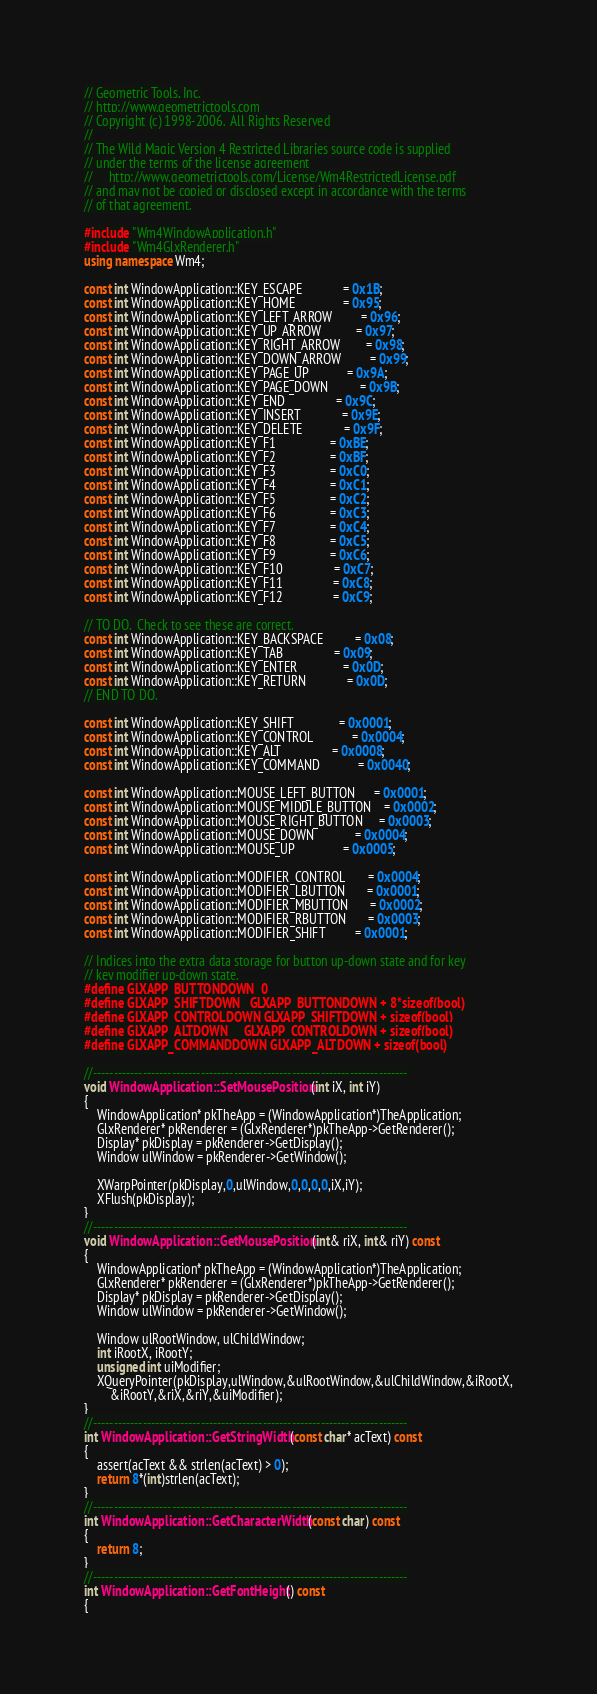Convert code to text. <code><loc_0><loc_0><loc_500><loc_500><_C++_>// Geometric Tools, Inc.
// http://www.geometrictools.com
// Copyright (c) 1998-2006.  All Rights Reserved
//
// The Wild Magic Version 4 Restricted Libraries source code is supplied
// under the terms of the license agreement
//     http://www.geometrictools.com/License/Wm4RestrictedLicense.pdf
// and may not be copied or disclosed except in accordance with the terms
// of that agreement.

#include "Wm4WindowApplication.h"
#include "Wm4GlxRenderer.h"
using namespace Wm4;

const int WindowApplication::KEY_ESCAPE             = 0x1B;
const int WindowApplication::KEY_HOME               = 0x95;
const int WindowApplication::KEY_LEFT_ARROW         = 0x96;
const int WindowApplication::KEY_UP_ARROW           = 0x97;
const int WindowApplication::KEY_RIGHT_ARROW        = 0x98;
const int WindowApplication::KEY_DOWN_ARROW         = 0x99;
const int WindowApplication::KEY_PAGE_UP            = 0x9A;
const int WindowApplication::KEY_PAGE_DOWN          = 0x9B;
const int WindowApplication::KEY_END                = 0x9C;
const int WindowApplication::KEY_INSERT             = 0x9E;
const int WindowApplication::KEY_DELETE             = 0x9F;
const int WindowApplication::KEY_F1                 = 0xBE;
const int WindowApplication::KEY_F2                 = 0xBF;
const int WindowApplication::KEY_F3                 = 0xC0;
const int WindowApplication::KEY_F4                 = 0xC1;
const int WindowApplication::KEY_F5                 = 0xC2;
const int WindowApplication::KEY_F6                 = 0xC3;
const int WindowApplication::KEY_F7                 = 0xC4;
const int WindowApplication::KEY_F8                 = 0xC5;
const int WindowApplication::KEY_F9                 = 0xC6;
const int WindowApplication::KEY_F10                = 0xC7;
const int WindowApplication::KEY_F11                = 0xC8;
const int WindowApplication::KEY_F12                = 0xC9;

// TO DO.  Check to see these are correct.
const int WindowApplication::KEY_BACKSPACE          = 0x08;
const int WindowApplication::KEY_TAB                = 0x09;
const int WindowApplication::KEY_ENTER              = 0x0D;
const int WindowApplication::KEY_RETURN             = 0x0D;
// END TO DO.

const int WindowApplication::KEY_SHIFT              = 0x0001;
const int WindowApplication::KEY_CONTROL            = 0x0004;
const int WindowApplication::KEY_ALT                = 0x0008;
const int WindowApplication::KEY_COMMAND            = 0x0040;

const int WindowApplication::MOUSE_LEFT_BUTTON      = 0x0001;
const int WindowApplication::MOUSE_MIDDLE_BUTTON    = 0x0002;
const int WindowApplication::MOUSE_RIGHT_BUTTON     = 0x0003;
const int WindowApplication::MOUSE_DOWN             = 0x0004;
const int WindowApplication::MOUSE_UP               = 0x0005;

const int WindowApplication::MODIFIER_CONTROL       = 0x0004;
const int WindowApplication::MODIFIER_LBUTTON       = 0x0001;
const int WindowApplication::MODIFIER_MBUTTON       = 0x0002;
const int WindowApplication::MODIFIER_RBUTTON       = 0x0003;
const int WindowApplication::MODIFIER_SHIFT         = 0x0001;

// Indices into the extra data storage for button up-down state and for key
// key modifier up-down state.
#define GLXAPP_BUTTONDOWN  0
#define GLXAPP_SHIFTDOWN   GLXAPP_BUTTONDOWN + 8*sizeof(bool)
#define GLXAPP_CONTROLDOWN GLXAPP_SHIFTDOWN + sizeof(bool)
#define GLXAPP_ALTDOWN     GLXAPP_CONTROLDOWN + sizeof(bool)
#define GLXAPP_COMMANDDOWN GLXAPP_ALTDOWN + sizeof(bool)

//----------------------------------------------------------------------------
void WindowApplication::SetMousePosition (int iX, int iY)
{
    WindowApplication* pkTheApp = (WindowApplication*)TheApplication;
    GlxRenderer* pkRenderer = (GlxRenderer*)pkTheApp->GetRenderer();
    Display* pkDisplay = pkRenderer->GetDisplay();
    Window ulWindow = pkRenderer->GetWindow();

    XWarpPointer(pkDisplay,0,ulWindow,0,0,0,0,iX,iY);
    XFlush(pkDisplay);
}
//----------------------------------------------------------------------------
void WindowApplication::GetMousePosition (int& riX, int& riY) const
{
    WindowApplication* pkTheApp = (WindowApplication*)TheApplication;
    GlxRenderer* pkRenderer = (GlxRenderer*)pkTheApp->GetRenderer();
    Display* pkDisplay = pkRenderer->GetDisplay();
    Window ulWindow = pkRenderer->GetWindow();

    Window ulRootWindow, ulChildWindow;
    int iRootX, iRootY;
    unsigned int uiModifier;
    XQueryPointer(pkDisplay,ulWindow,&ulRootWindow,&ulChildWindow,&iRootX,
        &iRootY,&riX,&riY,&uiModifier);
}
//----------------------------------------------------------------------------
int WindowApplication::GetStringWidth (const char* acText) const
{
    assert(acText && strlen(acText) > 0);
    return 8*(int)strlen(acText);
}
//----------------------------------------------------------------------------
int WindowApplication::GetCharacterWidth (const char) const
{
    return 8;
}
//----------------------------------------------------------------------------
int WindowApplication::GetFontHeight () const
{</code> 